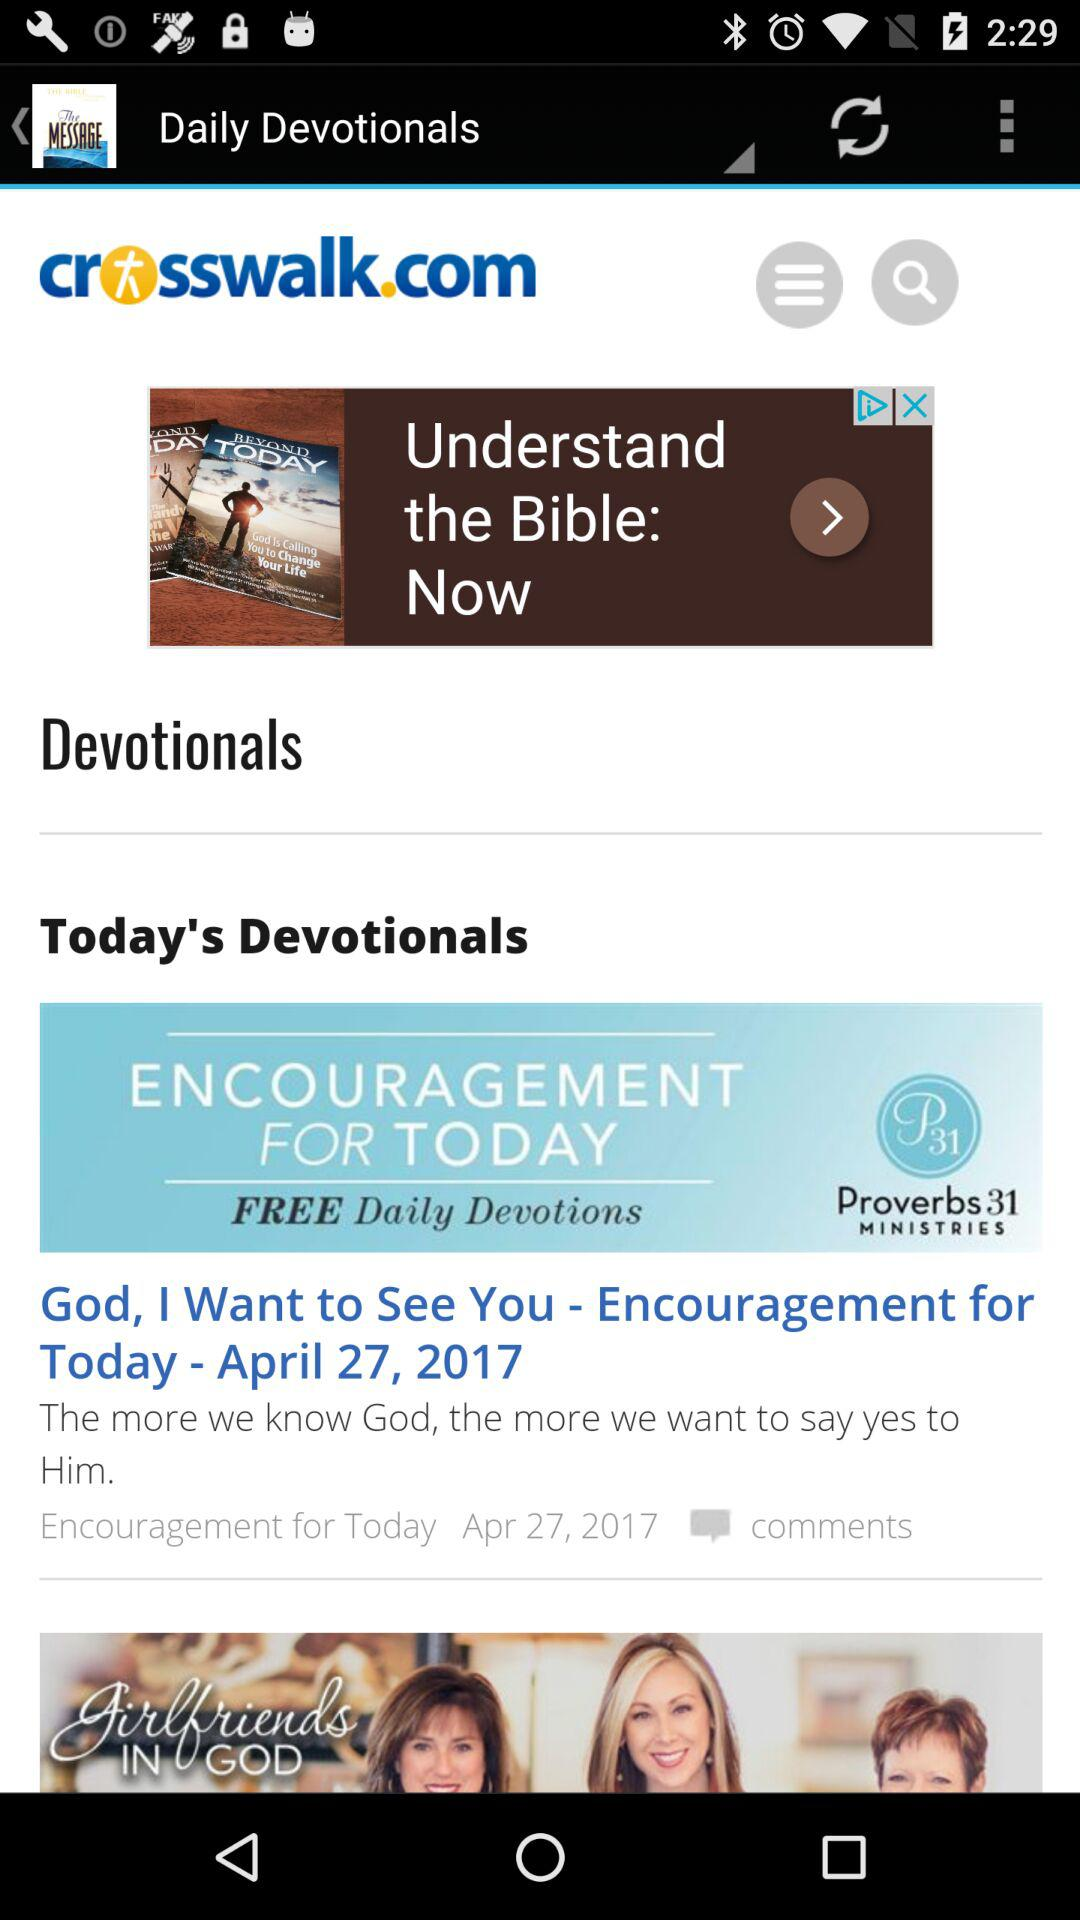What is the application name? The application name is "The Message Bible App Free". 